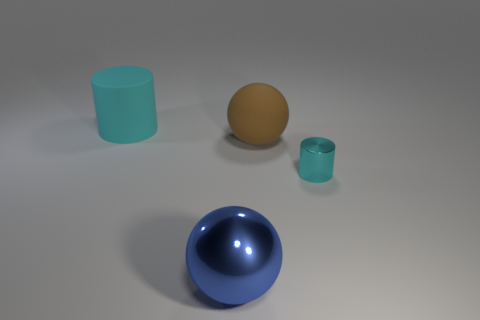Add 2 small green rubber cubes. How many objects exist? 6 Subtract all brown balls. How many balls are left? 1 Subtract 2 cylinders. How many cylinders are left? 0 Subtract all blue balls. Subtract all red rubber cubes. How many objects are left? 3 Add 3 big cyan rubber cylinders. How many big cyan rubber cylinders are left? 4 Add 2 big gray things. How many big gray things exist? 2 Subtract 0 yellow cylinders. How many objects are left? 4 Subtract all red cylinders. Subtract all green cubes. How many cylinders are left? 2 